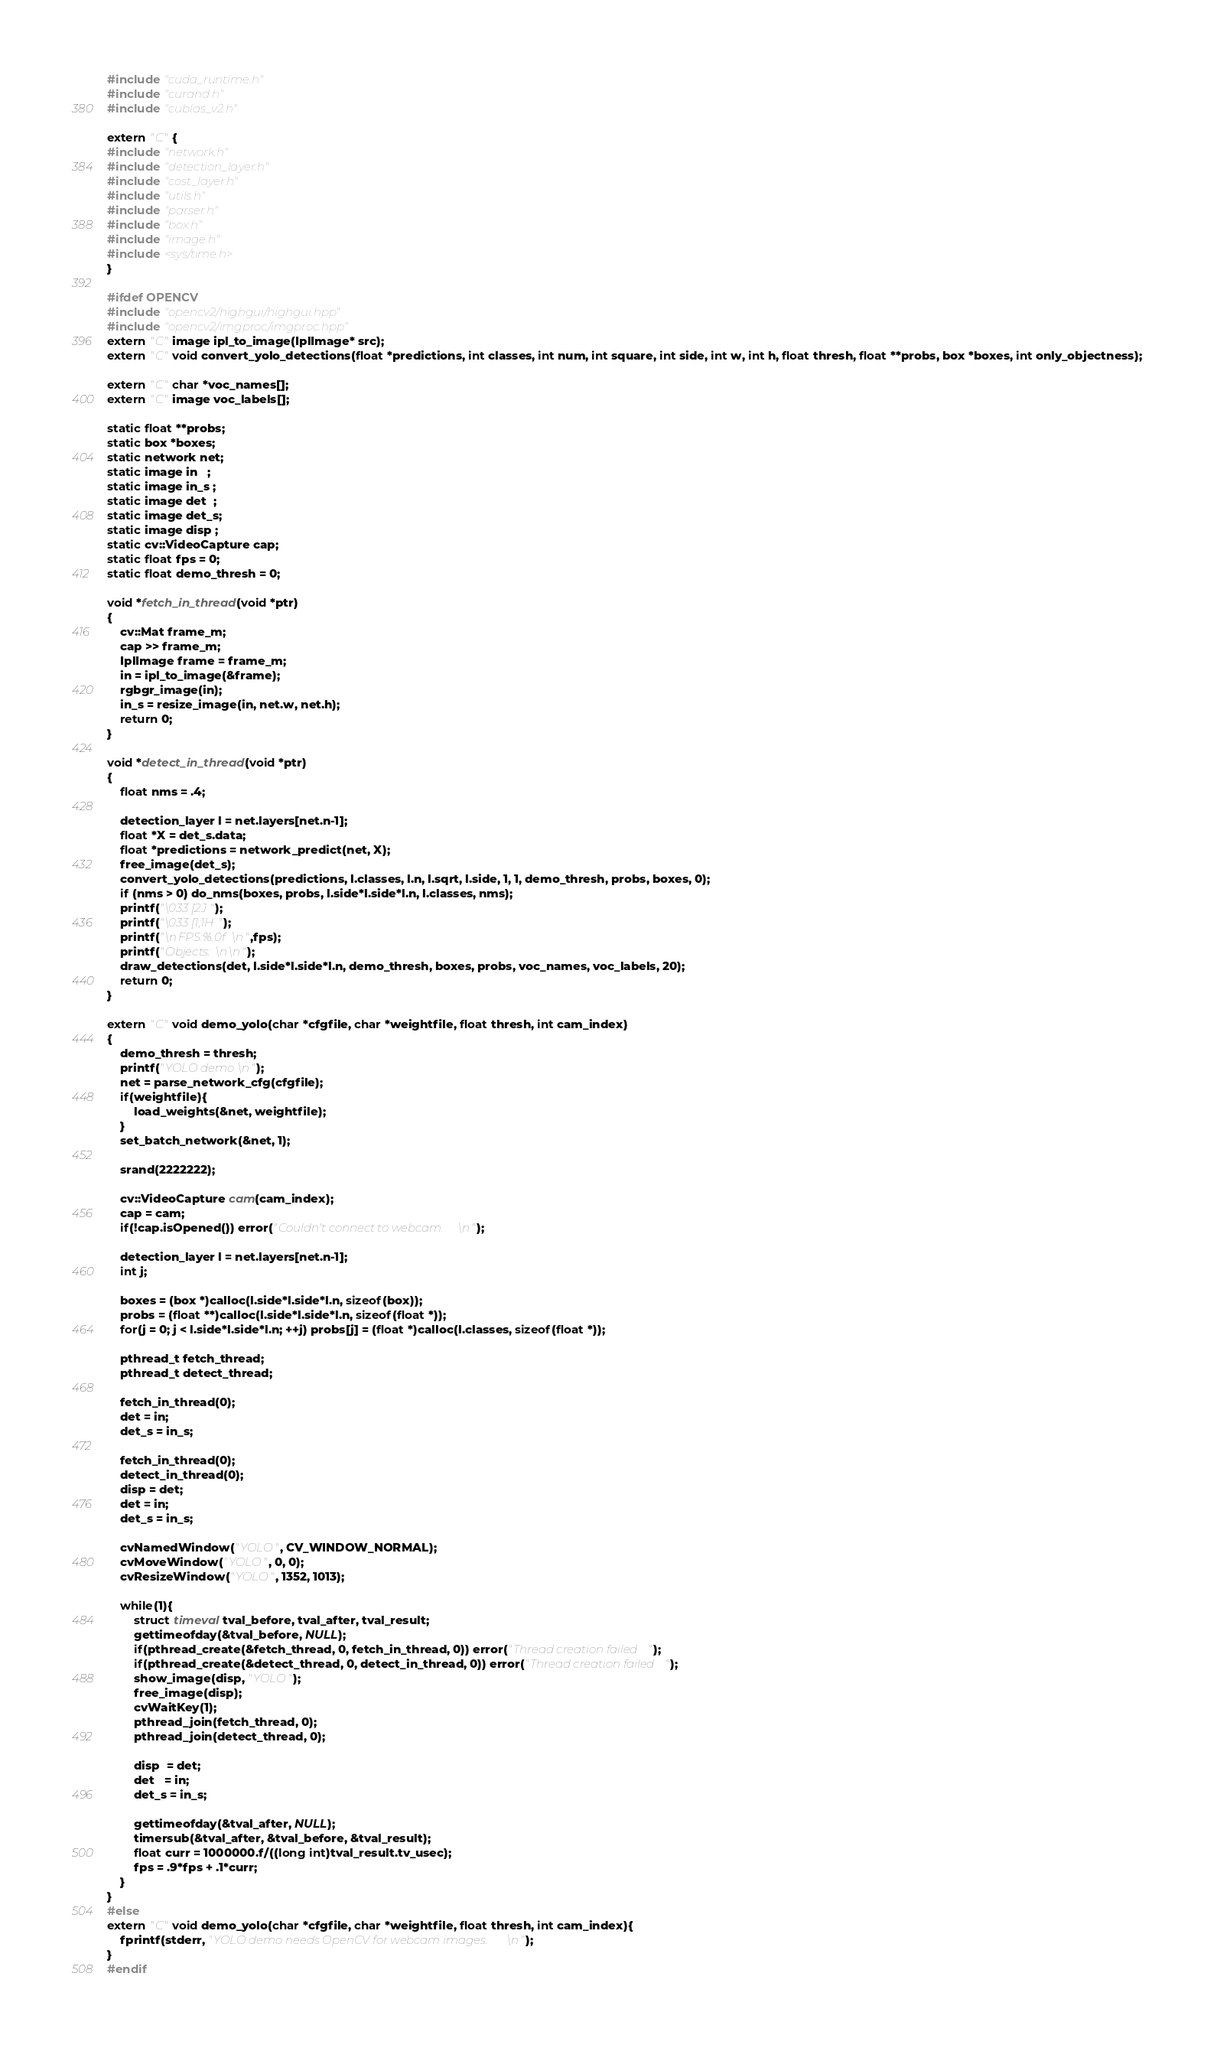<code> <loc_0><loc_0><loc_500><loc_500><_Cuda_>#include "cuda_runtime.h"
#include "curand.h"
#include "cublas_v2.h"

extern "C" {
#include "network.h"
#include "detection_layer.h"
#include "cost_layer.h"
#include "utils.h"
#include "parser.h"
#include "box.h"
#include "image.h"
#include <sys/time.h>
}

#ifdef OPENCV
#include "opencv2/highgui/highgui.hpp"
#include "opencv2/imgproc/imgproc.hpp"
extern "C" image ipl_to_image(IplImage* src);
extern "C" void convert_yolo_detections(float *predictions, int classes, int num, int square, int side, int w, int h, float thresh, float **probs, box *boxes, int only_objectness);

extern "C" char *voc_names[];
extern "C" image voc_labels[];

static float **probs;
static box *boxes;
static network net;
static image in   ;
static image in_s ;
static image det  ;
static image det_s;
static image disp ;
static cv::VideoCapture cap;
static float fps = 0;
static float demo_thresh = 0;

void *fetch_in_thread(void *ptr)
{
    cv::Mat frame_m;
    cap >> frame_m;
    IplImage frame = frame_m;
    in = ipl_to_image(&frame);
    rgbgr_image(in);
    in_s = resize_image(in, net.w, net.h);
    return 0;
}

void *detect_in_thread(void *ptr)
{
    float nms = .4;

    detection_layer l = net.layers[net.n-1];
    float *X = det_s.data;
    float *predictions = network_predict(net, X);
    free_image(det_s);
    convert_yolo_detections(predictions, l.classes, l.n, l.sqrt, l.side, 1, 1, demo_thresh, probs, boxes, 0);
    if (nms > 0) do_nms(boxes, probs, l.side*l.side*l.n, l.classes, nms);
    printf("\033[2J");
    printf("\033[1;1H");
    printf("\nFPS:%.0f\n",fps);
    printf("Objects:\n\n");
    draw_detections(det, l.side*l.side*l.n, demo_thresh, boxes, probs, voc_names, voc_labels, 20);
    return 0;
}

extern "C" void demo_yolo(char *cfgfile, char *weightfile, float thresh, int cam_index)
{
    demo_thresh = thresh;
    printf("YOLO demo\n");
    net = parse_network_cfg(cfgfile);
    if(weightfile){
        load_weights(&net, weightfile);
    }
    set_batch_network(&net, 1);

    srand(2222222);

    cv::VideoCapture cam(cam_index);
    cap = cam;
    if(!cap.isOpened()) error("Couldn't connect to webcam.\n");

    detection_layer l = net.layers[net.n-1];
    int j;

    boxes = (box *)calloc(l.side*l.side*l.n, sizeof(box));
    probs = (float **)calloc(l.side*l.side*l.n, sizeof(float *));
    for(j = 0; j < l.side*l.side*l.n; ++j) probs[j] = (float *)calloc(l.classes, sizeof(float *));

    pthread_t fetch_thread;
    pthread_t detect_thread;

    fetch_in_thread(0);
    det = in;
    det_s = in_s;

    fetch_in_thread(0);
    detect_in_thread(0);
    disp = det;
    det = in;
    det_s = in_s;

    cvNamedWindow("YOLO", CV_WINDOW_NORMAL); 
    cvMoveWindow("YOLO", 0, 0);
    cvResizeWindow("YOLO", 1352, 1013);

    while(1){
        struct timeval tval_before, tval_after, tval_result;
        gettimeofday(&tval_before, NULL);
        if(pthread_create(&fetch_thread, 0, fetch_in_thread, 0)) error("Thread creation failed");
        if(pthread_create(&detect_thread, 0, detect_in_thread, 0)) error("Thread creation failed");
        show_image(disp, "YOLO");
        free_image(disp);
        cvWaitKey(1);
        pthread_join(fetch_thread, 0);
        pthread_join(detect_thread, 0);

        disp  = det;
        det   = in;
        det_s = in_s;

        gettimeofday(&tval_after, NULL);
        timersub(&tval_after, &tval_before, &tval_result);
        float curr = 1000000.f/((long int)tval_result.tv_usec);
        fps = .9*fps + .1*curr;
    }
}
#else
extern "C" void demo_yolo(char *cfgfile, char *weightfile, float thresh, int cam_index){
    fprintf(stderr, "YOLO demo needs OpenCV for webcam images.\n");
}
#endif

</code> 